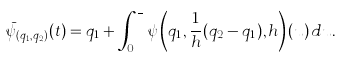Convert formula to latex. <formula><loc_0><loc_0><loc_500><loc_500>\bar { \psi } _ { ( q _ { 1 } , q _ { 2 } ) } ( t ) = q _ { 1 } + \int _ { 0 } ^ { \frac { t } { h } } \psi \left ( q _ { 1 } , \frac { 1 } { h } ( q _ { 2 } - q _ { 1 } ) , h \right ) ( u ) \, d u .</formula> 